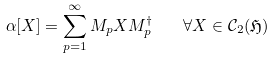<formula> <loc_0><loc_0><loc_500><loc_500>\alpha [ X ] = \sum _ { p = 1 } ^ { \infty } M _ { p } X M _ { p } ^ { \dagger } \quad \forall X \in \mathcal { C } _ { 2 } ( \mathfrak { H } )</formula> 